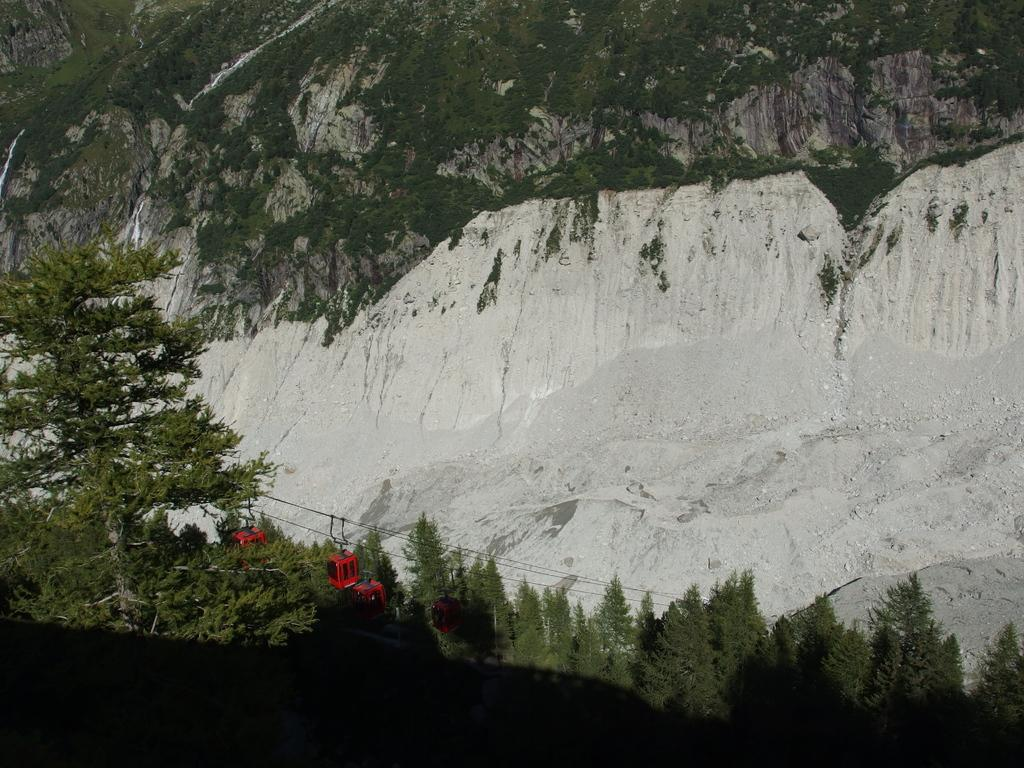What can be seen at the bottom of the image? There are wires and cable cars at the bottom of the image. What type of natural features are visible in the image? Trees and mountains are visible in the image. What is the source of the shadow at the bottom of the image? The shadow at the bottom of the image is likely caused by the cable cars or other objects in the scene. What type of treatment is being administered to the trees in the image? There is no indication in the image that any treatment is being administered to the trees. 